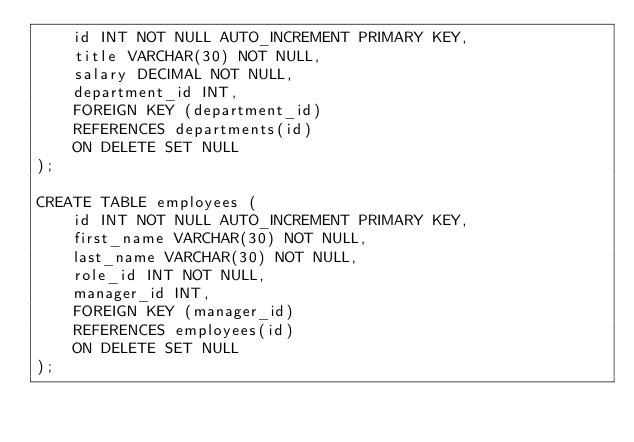Convert code to text. <code><loc_0><loc_0><loc_500><loc_500><_SQL_>    id INT NOT NULL AUTO_INCREMENT PRIMARY KEY,
    title VARCHAR(30) NOT NULL,
    salary DECIMAL NOT NULL,
    department_id INT,
    FOREIGN KEY (department_id)
    REFERENCES departments(id) 
    ON DELETE SET NULL
);

CREATE TABLE employees (
    id INT NOT NULL AUTO_INCREMENT PRIMARY KEY,
    first_name VARCHAR(30) NOT NULL,
    last_name VARCHAR(30) NOT NULL,
    role_id INT NOT NULL,
    manager_id INT,
    FOREIGN KEY (manager_id)
    REFERENCES employees(id)
    ON DELETE SET NULL
);</code> 